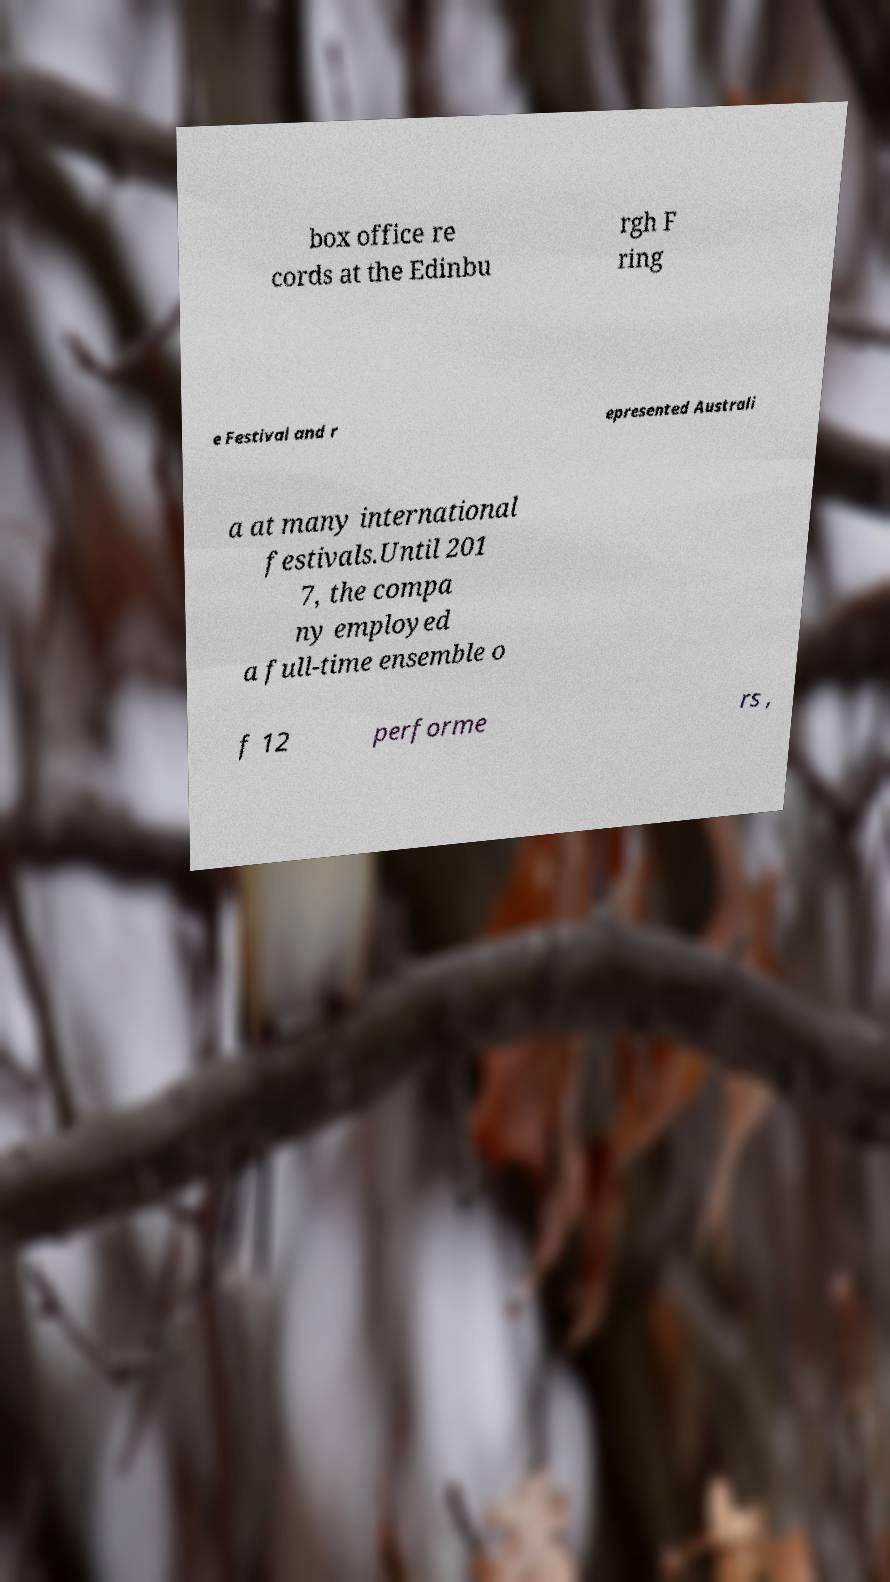Please read and relay the text visible in this image. What does it say? box office re cords at the Edinbu rgh F ring e Festival and r epresented Australi a at many international festivals.Until 201 7, the compa ny employed a full-time ensemble o f 12 performe rs , 